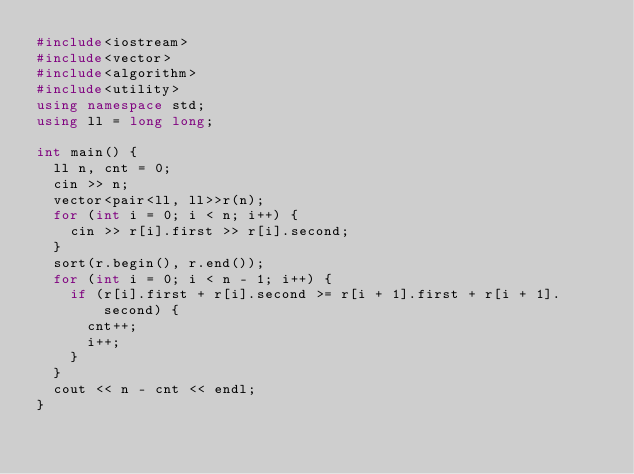<code> <loc_0><loc_0><loc_500><loc_500><_C++_>#include<iostream>
#include<vector>
#include<algorithm>
#include<utility>
using namespace std;
using ll = long long;

int main() {
	ll n, cnt = 0;
	cin >> n;
	vector<pair<ll, ll>>r(n);
	for (int i = 0; i < n; i++) {
		cin >> r[i].first >> r[i].second;
	}
	sort(r.begin(), r.end());
	for (int i = 0; i < n - 1; i++) {
		if (r[i].first + r[i].second >= r[i + 1].first + r[i + 1].second) {
			cnt++;
			i++;
		}
	}
	cout << n - cnt << endl;
}</code> 